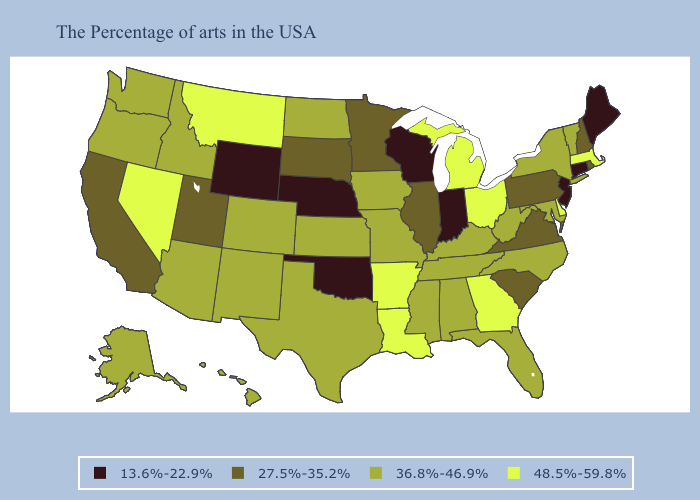Name the states that have a value in the range 36.8%-46.9%?
Give a very brief answer. Vermont, New York, Maryland, North Carolina, West Virginia, Florida, Kentucky, Alabama, Tennessee, Mississippi, Missouri, Iowa, Kansas, Texas, North Dakota, Colorado, New Mexico, Arizona, Idaho, Washington, Oregon, Alaska, Hawaii. Among the states that border Illinois , does Wisconsin have the highest value?
Keep it brief. No. Which states have the lowest value in the USA?
Be succinct. Maine, Connecticut, New Jersey, Indiana, Wisconsin, Nebraska, Oklahoma, Wyoming. Which states have the highest value in the USA?
Answer briefly. Massachusetts, Delaware, Ohio, Georgia, Michigan, Louisiana, Arkansas, Montana, Nevada. How many symbols are there in the legend?
Quick response, please. 4. Which states have the lowest value in the West?
Concise answer only. Wyoming. What is the value of Utah?
Give a very brief answer. 27.5%-35.2%. Which states hav the highest value in the Northeast?
Be succinct. Massachusetts. What is the value of New Jersey?
Write a very short answer. 13.6%-22.9%. Among the states that border Kansas , does Oklahoma have the lowest value?
Answer briefly. Yes. What is the value of Utah?
Write a very short answer. 27.5%-35.2%. Among the states that border Arizona , which have the highest value?
Give a very brief answer. Nevada. Among the states that border Virginia , which have the highest value?
Answer briefly. Maryland, North Carolina, West Virginia, Kentucky, Tennessee. Does the first symbol in the legend represent the smallest category?
Answer briefly. Yes. Which states have the highest value in the USA?
Short answer required. Massachusetts, Delaware, Ohio, Georgia, Michigan, Louisiana, Arkansas, Montana, Nevada. 